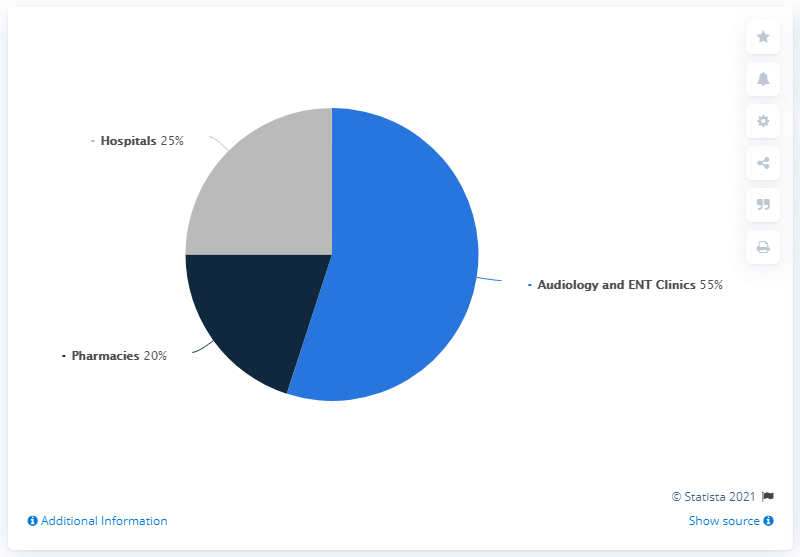List a handful of essential elements in this visual. Pharmacies accounted for a significant portion of the global hearing aid market in 2018, with their market share exceeding 20%. According to a recent report, in 2018, hospitals, audiology clinics, and ear, nose and throat (ENT) clinics accounted for approximately 80% of the global hearing aid market share. 